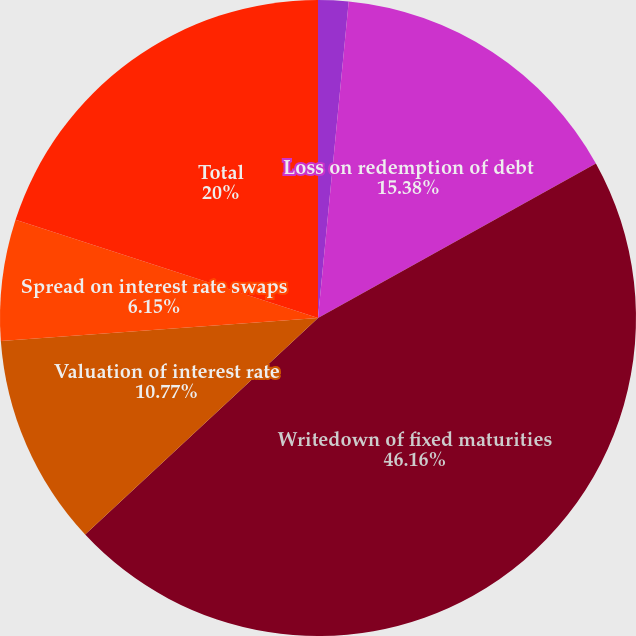Convert chart to OTSL. <chart><loc_0><loc_0><loc_500><loc_500><pie_chart><fcel>Investment sales and calls<fcel>Loss on redemption of debt<fcel>Writedown of fixed maturities<fcel>Valuation of interest rate<fcel>Spread on interest rate swaps<fcel>Total<nl><fcel>1.54%<fcel>15.38%<fcel>46.15%<fcel>10.77%<fcel>6.15%<fcel>20.0%<nl></chart> 